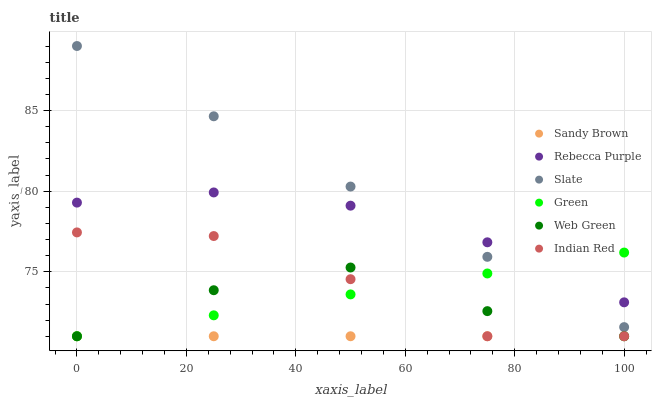Does Sandy Brown have the minimum area under the curve?
Answer yes or no. Yes. Does Slate have the maximum area under the curve?
Answer yes or no. Yes. Does Web Green have the minimum area under the curve?
Answer yes or no. No. Does Web Green have the maximum area under the curve?
Answer yes or no. No. Is Sandy Brown the smoothest?
Answer yes or no. Yes. Is Indian Red the roughest?
Answer yes or no. Yes. Is Web Green the smoothest?
Answer yes or no. No. Is Web Green the roughest?
Answer yes or no. No. Does Web Green have the lowest value?
Answer yes or no. Yes. Does Rebecca Purple have the lowest value?
Answer yes or no. No. Does Slate have the highest value?
Answer yes or no. Yes. Does Web Green have the highest value?
Answer yes or no. No. Is Web Green less than Slate?
Answer yes or no. Yes. Is Slate greater than Web Green?
Answer yes or no. Yes. Does Green intersect Slate?
Answer yes or no. Yes. Is Green less than Slate?
Answer yes or no. No. Is Green greater than Slate?
Answer yes or no. No. Does Web Green intersect Slate?
Answer yes or no. No. 